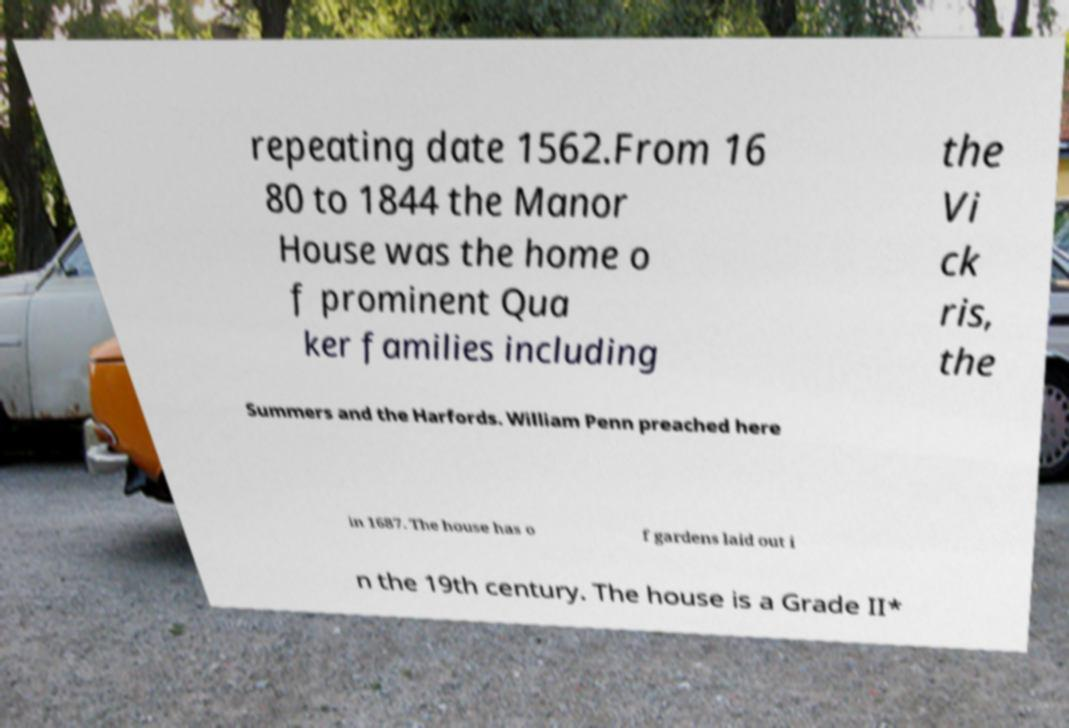For documentation purposes, I need the text within this image transcribed. Could you provide that? repeating date 1562.From 16 80 to 1844 the Manor House was the home o f prominent Qua ker families including the Vi ck ris, the Summers and the Harfords. William Penn preached here in 1687. The house has o f gardens laid out i n the 19th century. The house is a Grade II* 